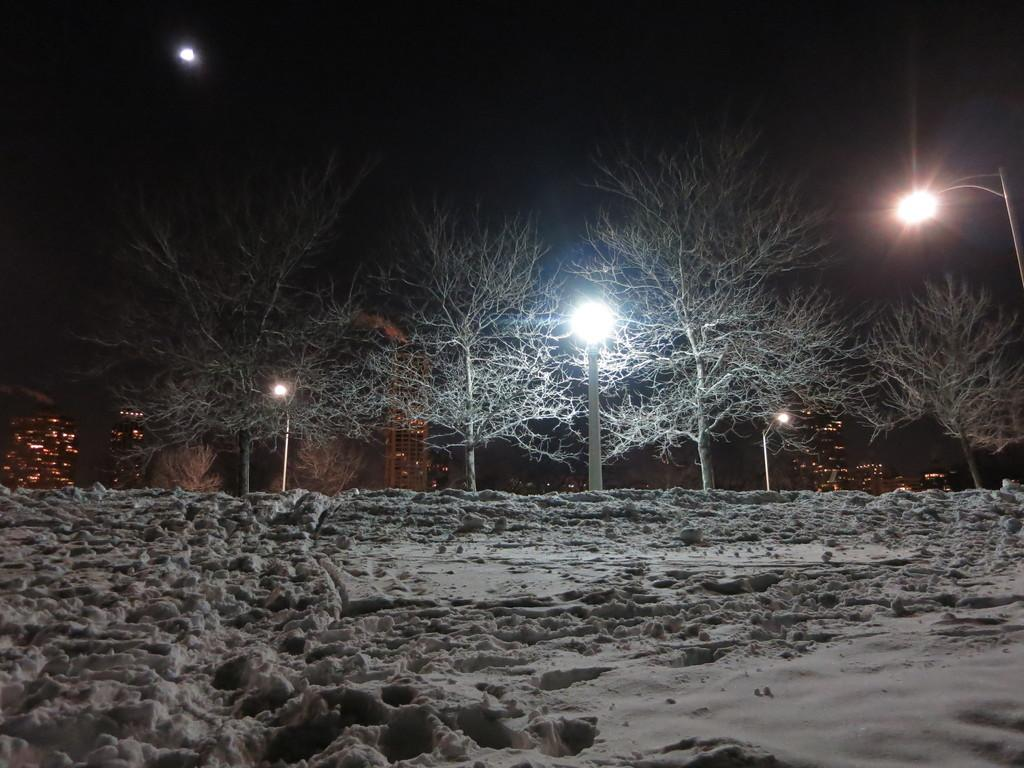What type of ground is visible in the image? There is sand on the ground in the image. What type of vegetation can be seen in the image? There are trees in the image. What type of structures are present in the image? There are street light poles and buildings in the image. What is the lighting condition in the top part of the image? The top part of the image is dark. Can you see a nest in the trees in the image? There is no nest visible in the trees in the image. What type of prose is being recited by the street light poles in the image? The street light poles are not reciting any prose; they are inanimate objects. 